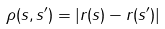<formula> <loc_0><loc_0><loc_500><loc_500>\rho ( s , s ^ { \prime } ) = | { r } ( s ) - { r } ( s ^ { \prime } ) |</formula> 